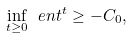<formula> <loc_0><loc_0><loc_500><loc_500>\inf _ { t \geq 0 } \ e n t ^ { t } & \geq - C _ { 0 } ,</formula> 